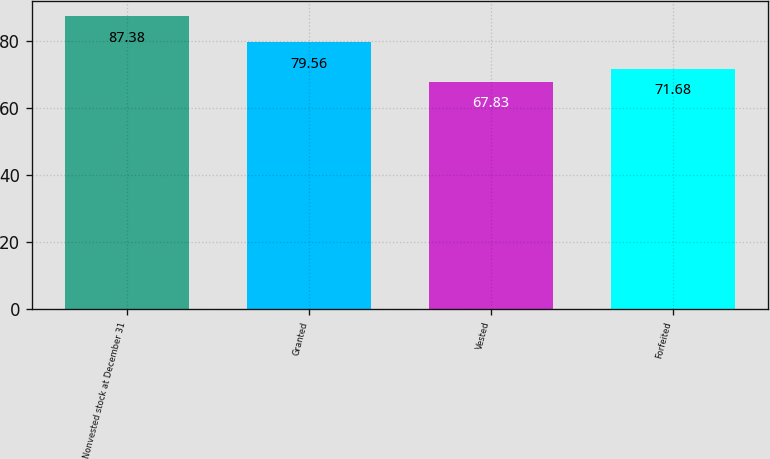Convert chart. <chart><loc_0><loc_0><loc_500><loc_500><bar_chart><fcel>Nonvested stock at December 31<fcel>Granted<fcel>Vested<fcel>Forfeited<nl><fcel>87.38<fcel>79.56<fcel>67.83<fcel>71.68<nl></chart> 